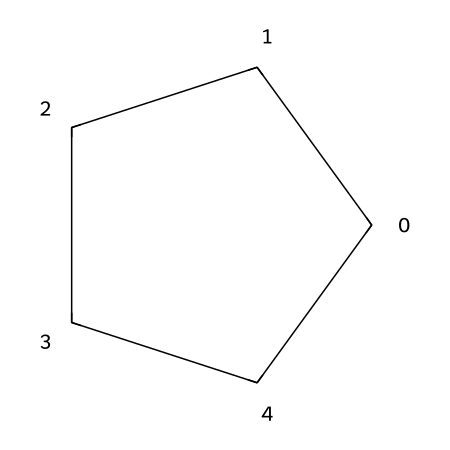What is the name of this chemical? The SMILES representation "C1CCCC1" corresponds to a molecule with a ring structure composed of five carbon atoms. This is the definition of cyclopentane, which contains five carbon atoms arranged in a cyclic format.
Answer: cyclopentane How many carbon atoms are present in the molecule? Analyzing the SMILES, "C1CCCC1" indicates that there are five 'C' atoms in the ring structure, confirming the presence of five carbon atoms in cyclopentane.
Answer: five What type of structure does this chemical have? The notation "C1...C1" signifies that the carbon atoms are connected in a cyclic manner, indicating that this is a cycloalkane. The cyclical connectivity is a definitive characteristic of such structures.
Answer: cyclic Why is cyclopentane important in synthetic resin adhesives? Cyclopentane acts as a solvent and a diluent in synthetic resin adhesives, influencing the viscosity and setting properties, which is crucial in art framing projects. This enhances adhesion effectiveness and drying times.
Answer: solvent What is the molecular formula of cyclopentane? By identifying the number of carbon and hydrogen atoms based on its structure, cyclopentane contains five carbon atoms and twelve hydrogen atoms, which gives its molecular formula as C5H10.
Answer: C5H10 How does the saturation of cyclopentane compare to alkenes? Cyclopentane is a saturated hydrocarbon, meaning all carbon-carbon bonds are single bonds, as opposed to alkenes which contain at least one double bond, rendering cyclopentane more stable in comparison.
Answer: saturated What impact does the ring structure of cyclopentane have on its reactivity? The ring structure contributes to cyclopentane's stability and makes it less reactive than open-chain hydrocarbons, as the cyclic arrangement creates strain that complicates reactions compared to more linear forms.
Answer: stability 